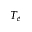Convert formula to latex. <formula><loc_0><loc_0><loc_500><loc_500>T _ { e }</formula> 